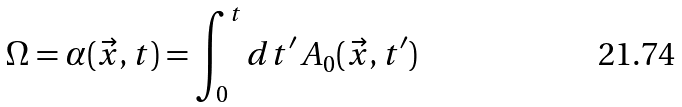<formula> <loc_0><loc_0><loc_500><loc_500>\Omega = \alpha ( \vec { x } , t ) = \int _ { 0 } ^ { t } d t ^ { \prime } \, A _ { 0 } ( \vec { x } , t ^ { \prime } )</formula> 